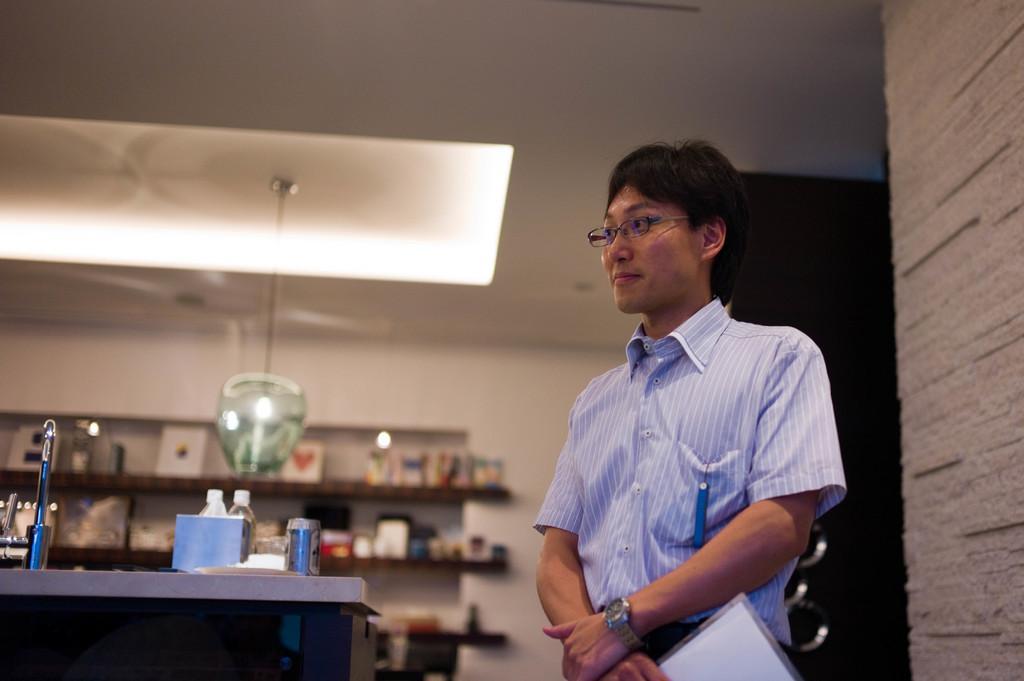Describe this image in one or two sentences. In this image there is a person in a room holding a paper and there is a blue color object in his pocket, there are few objects arranged on the shelves, there are bottles, a tin and some other objects on the desk, a light hanging from the roof. 